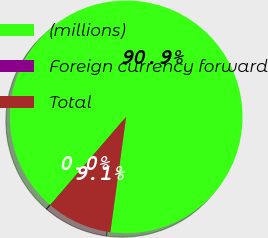Convert chart to OTSL. <chart><loc_0><loc_0><loc_500><loc_500><pie_chart><fcel>(millions)<fcel>Foreign currency forward<fcel>Total<nl><fcel>90.86%<fcel>0.03%<fcel>9.11%<nl></chart> 